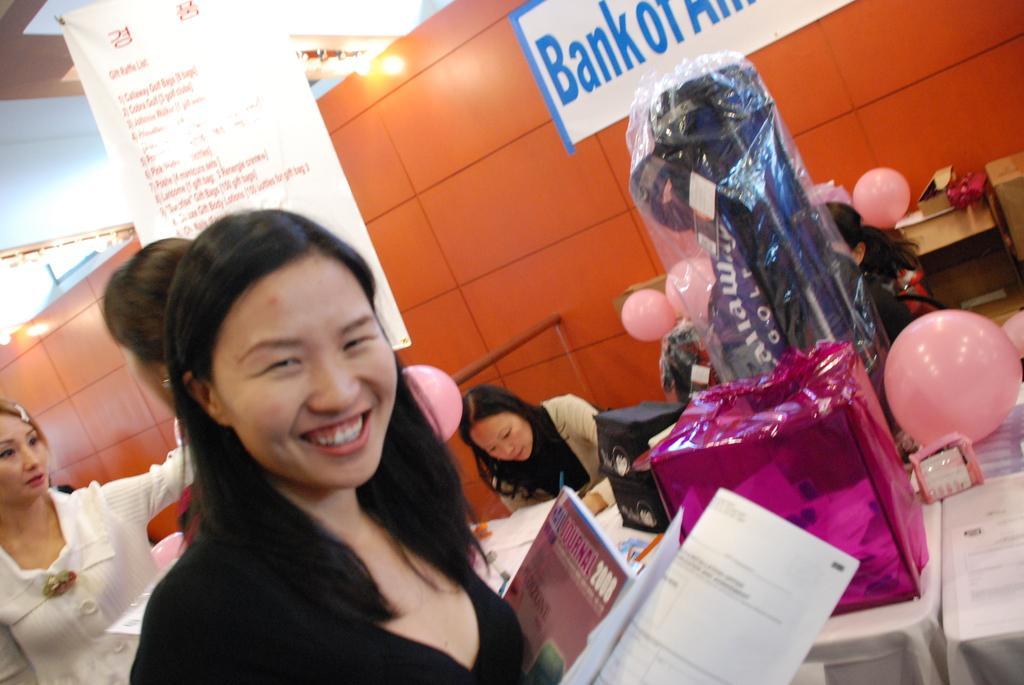In one or two sentences, can you explain what this image depicts? This picture describes about group of people, on the left side of the image we can see a woman, she is smiling and she is holding papers, in the background we can see few lights, hoarding, balloons and a gift box on the table. 